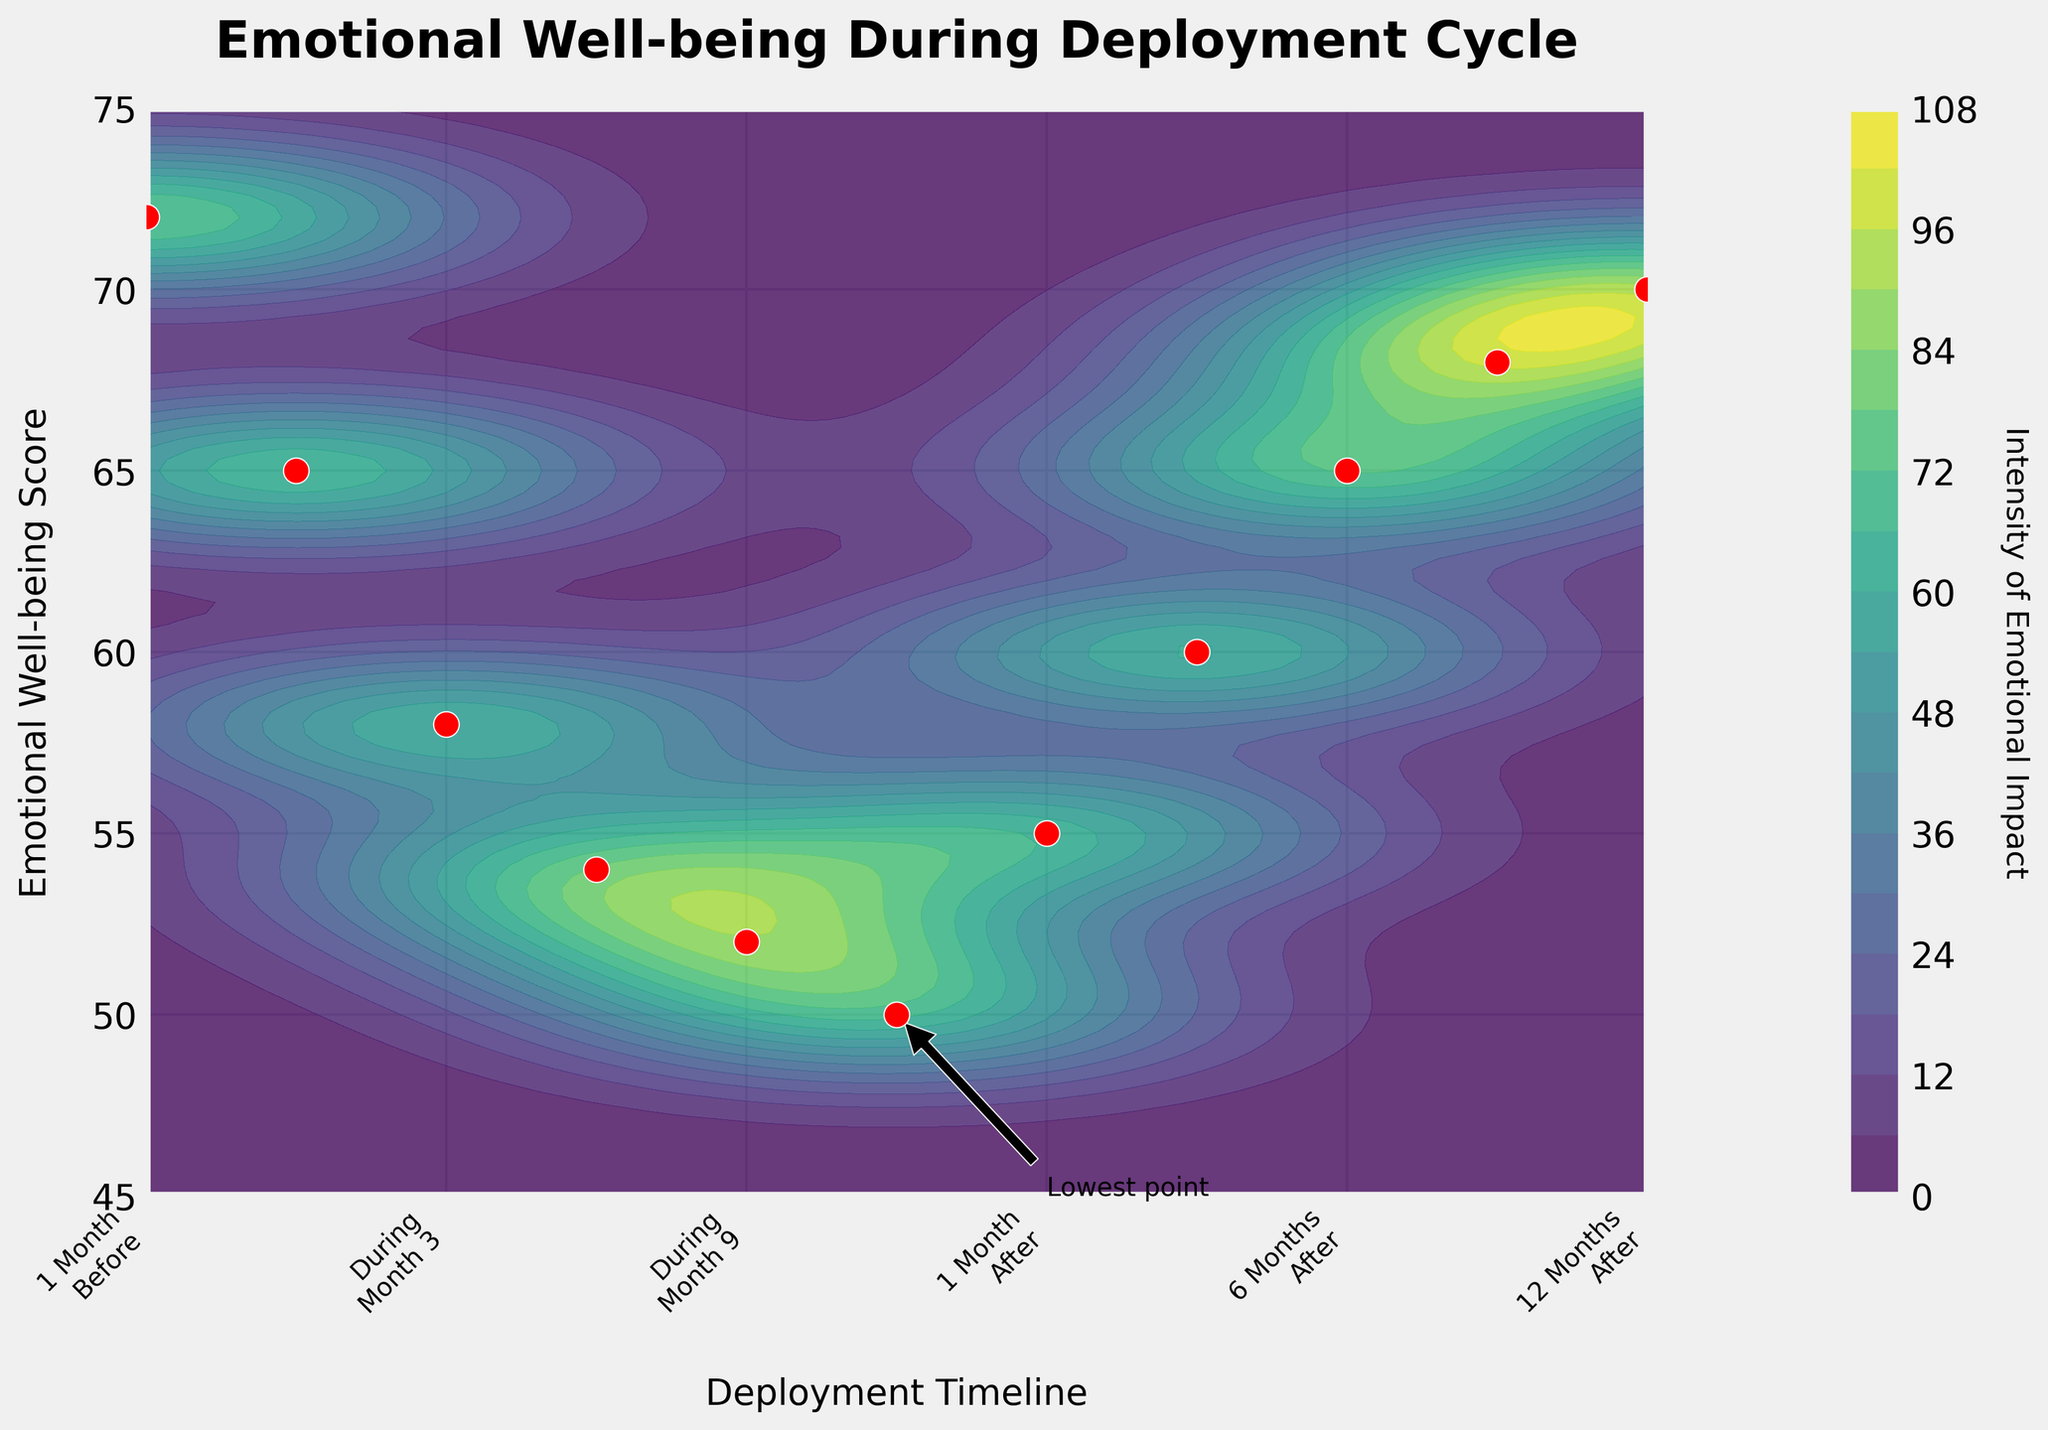What is the title of the plot? The title of the plot is typically displayed at the top and summarizes the main idea. For this plot, it is written in bold font.
Answer: Emotional Well-being During Deployment Cycle What are the labels of the x-axis and y-axis? Labels provide information about what the axes represent. They are generally positioned alongside the respective axes. The x-axis label describes the timeline, and the y-axis label describes the scores.
Answer: Deployment Timeline; Emotional Well-being Score At which point in time is the emotional well-being score the lowest? To find the lowest score, look at the scatter points and find the one at the lowest position on the y-axis. The label near this point indicates the time period.
Answer: During Deployment Month 12 How does the emotional well-being score change from "1 Month Before Deployment" to "12 Months After Return"? To answer this, observe the scores at the specific time points on the scatter plot. Note down each score and track their changes over the given time periods.
Answer: Decreases to 50; increases to 70 What is the difference in the emotional well-being score between "During Deployment Month 1" and "During Deployment Month 12"? First, identify the scores at these two points. The score for "During Deployment Month 1" is 65 and for "During Deployment Month 12" is 50. Subtract the latter from the former.
Answer: 15 How does the color intensity of the contour plot change over time? Focus on the shades of colors in the plot which depict the intensity. Light colors generally indicate higher scores while darker colors indicate lower scores.
Answer: Decreases during deployment; increases after return Which time period has the most prominent peak in emotional well-being score? Peaks are points where the score is highest relative to surrounding points. Check the high points on the scatter plot and confirm with contour intensity.
Answer: 1 Month Before Deployment What is the emotional well-being score at "3 Months After Return"? Locate the scatter point which aligns with "3 Months After Return" and read the corresponding y-value.
Answer: 60 Is there any point with the same emotional well-being score before and after deployment? Compare specific scores during the time periods before and after deployment to see if any values match.
Answer: Yes, 65 (1 Month Before Deployment and 6 Months After Return) How is the overall trend of emotional well-being scores depicted in the plot? Observe the general direction of the scatter points and the contour plot to understand the overall pattern or trend over time.
Answer: Decreasing during deployment; increasing after return 